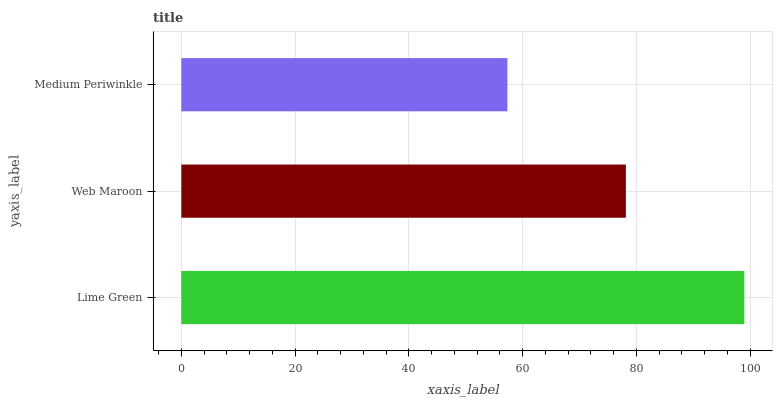Is Medium Periwinkle the minimum?
Answer yes or no. Yes. Is Lime Green the maximum?
Answer yes or no. Yes. Is Web Maroon the minimum?
Answer yes or no. No. Is Web Maroon the maximum?
Answer yes or no. No. Is Lime Green greater than Web Maroon?
Answer yes or no. Yes. Is Web Maroon less than Lime Green?
Answer yes or no. Yes. Is Web Maroon greater than Lime Green?
Answer yes or no. No. Is Lime Green less than Web Maroon?
Answer yes or no. No. Is Web Maroon the high median?
Answer yes or no. Yes. Is Web Maroon the low median?
Answer yes or no. Yes. Is Lime Green the high median?
Answer yes or no. No. Is Lime Green the low median?
Answer yes or no. No. 